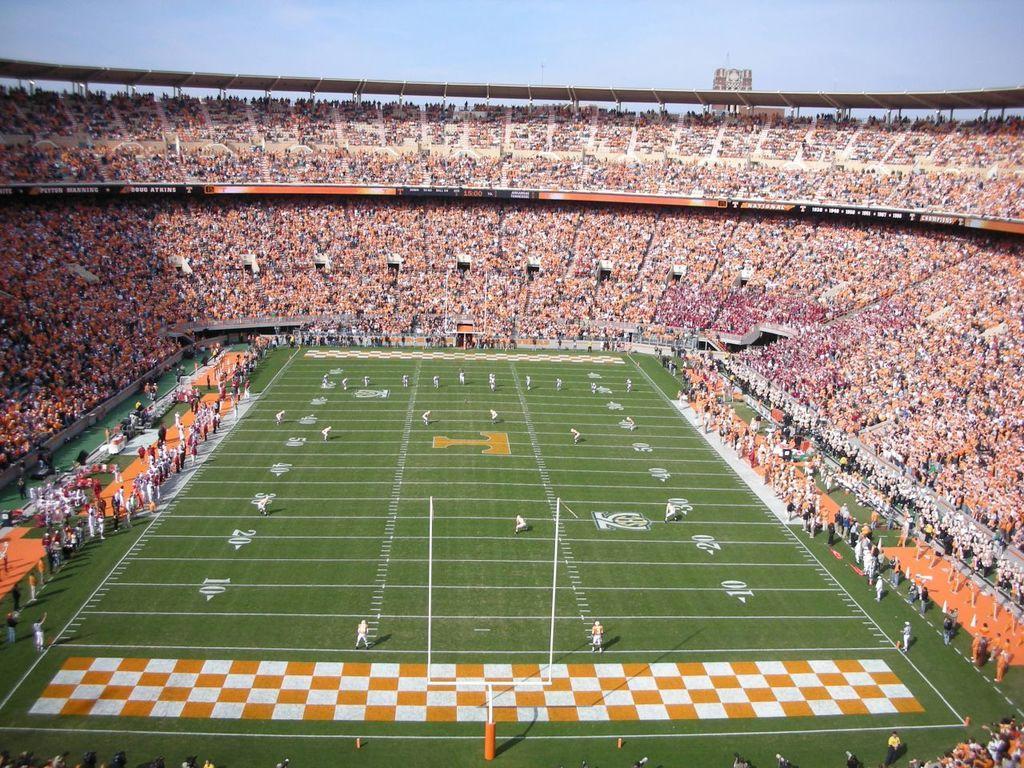Provide a one-sentence caption for the provided image. An orange T is at the center of the football field. 